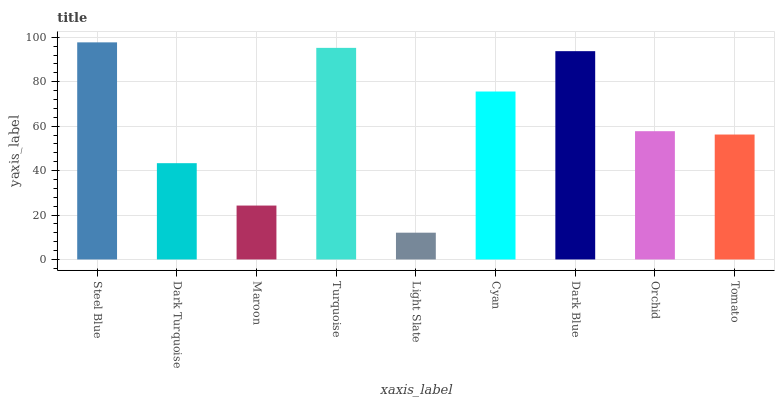Is Light Slate the minimum?
Answer yes or no. Yes. Is Steel Blue the maximum?
Answer yes or no. Yes. Is Dark Turquoise the minimum?
Answer yes or no. No. Is Dark Turquoise the maximum?
Answer yes or no. No. Is Steel Blue greater than Dark Turquoise?
Answer yes or no. Yes. Is Dark Turquoise less than Steel Blue?
Answer yes or no. Yes. Is Dark Turquoise greater than Steel Blue?
Answer yes or no. No. Is Steel Blue less than Dark Turquoise?
Answer yes or no. No. Is Orchid the high median?
Answer yes or no. Yes. Is Orchid the low median?
Answer yes or no. Yes. Is Dark Blue the high median?
Answer yes or no. No. Is Tomato the low median?
Answer yes or no. No. 